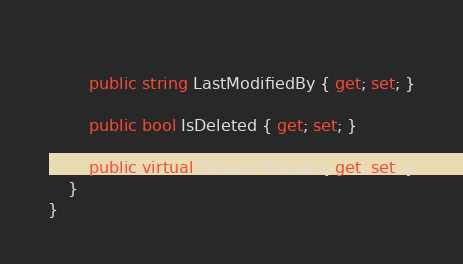<code> <loc_0><loc_0><loc_500><loc_500><_C#_>        
		public string LastModifiedBy { get; set; }
        
		public bool IsDeleted { get; set; }

        public virtual Tenant Tenant { get; set; }
    }
}
</code> 